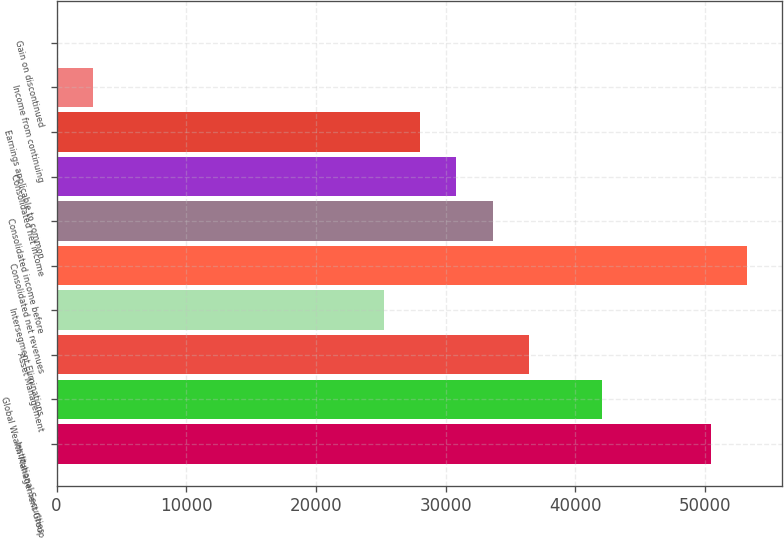Convert chart to OTSL. <chart><loc_0><loc_0><loc_500><loc_500><bar_chart><fcel>Institutional Securities<fcel>Global Wealth Management Group<fcel>Asset Management<fcel>Intersegment Eliminations<fcel>Consolidated net revenues<fcel>Consolidated income before<fcel>Consolidated net income<fcel>Earnings applicable to common<fcel>Income from continuing<fcel>Gain on discontinued<nl><fcel>50446.4<fcel>42038.7<fcel>36433.7<fcel>25223.5<fcel>53248.9<fcel>33631.1<fcel>30828.6<fcel>28026<fcel>2803.18<fcel>0.64<nl></chart> 